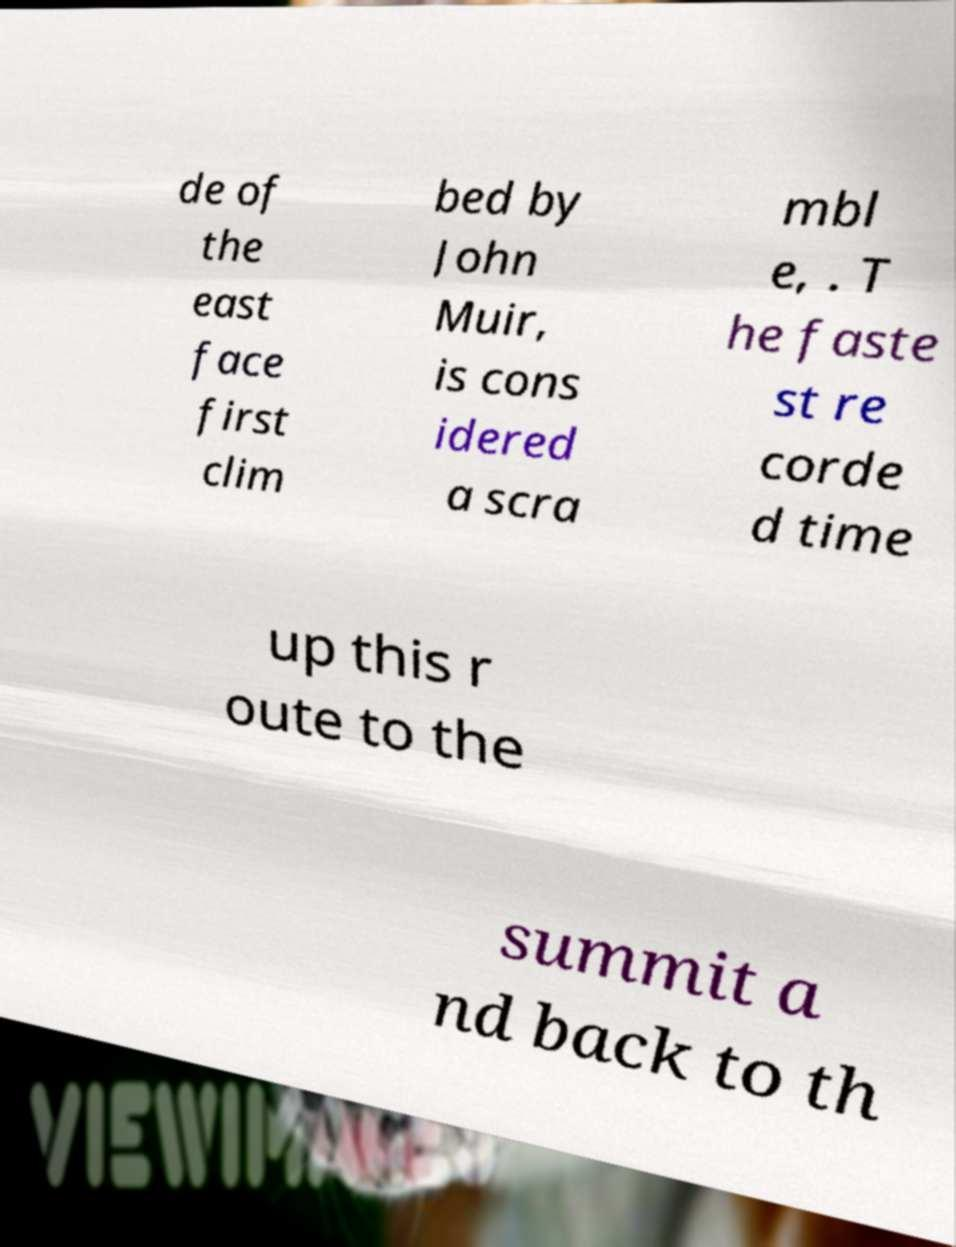What messages or text are displayed in this image? I need them in a readable, typed format. de of the east face first clim bed by John Muir, is cons idered a scra mbl e, . T he faste st re corde d time up this r oute to the summit a nd back to th 